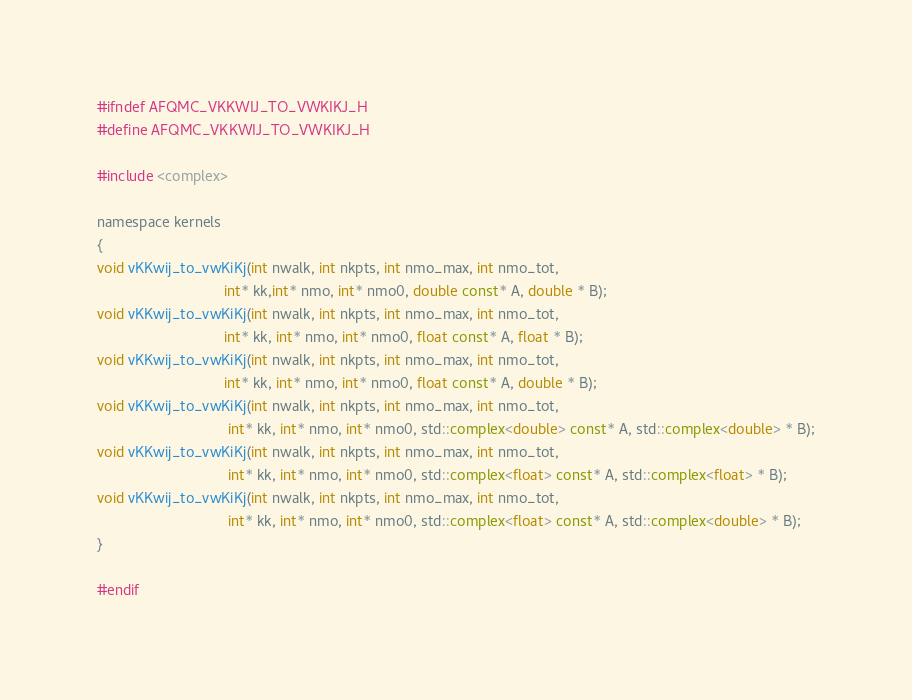<code> <loc_0><loc_0><loc_500><loc_500><_Cuda_>#ifndef AFQMC_VKKWIJ_TO_VWKIKJ_H
#define AFQMC_VKKWIJ_TO_VWKIKJ_H

#include <complex>

namespace kernels
{
void vKKwij_to_vwKiKj(int nwalk, int nkpts, int nmo_max, int nmo_tot,
                               int* kk,int* nmo, int* nmo0, double const* A, double * B);
void vKKwij_to_vwKiKj(int nwalk, int nkpts, int nmo_max, int nmo_tot,
                               int* kk, int* nmo, int* nmo0, float const* A, float * B);
void vKKwij_to_vwKiKj(int nwalk, int nkpts, int nmo_max, int nmo_tot,
                               int* kk, int* nmo, int* nmo0, float const* A, double * B);
void vKKwij_to_vwKiKj(int nwalk, int nkpts, int nmo_max, int nmo_tot,
                                int* kk, int* nmo, int* nmo0, std::complex<double> const* A, std::complex<double> * B);
void vKKwij_to_vwKiKj(int nwalk, int nkpts, int nmo_max, int nmo_tot,
                                int* kk, int* nmo, int* nmo0, std::complex<float> const* A, std::complex<float> * B);
void vKKwij_to_vwKiKj(int nwalk, int nkpts, int nmo_max, int nmo_tot,
                                int* kk, int* nmo, int* nmo0, std::complex<float> const* A, std::complex<double> * B);
}

#endif
</code> 